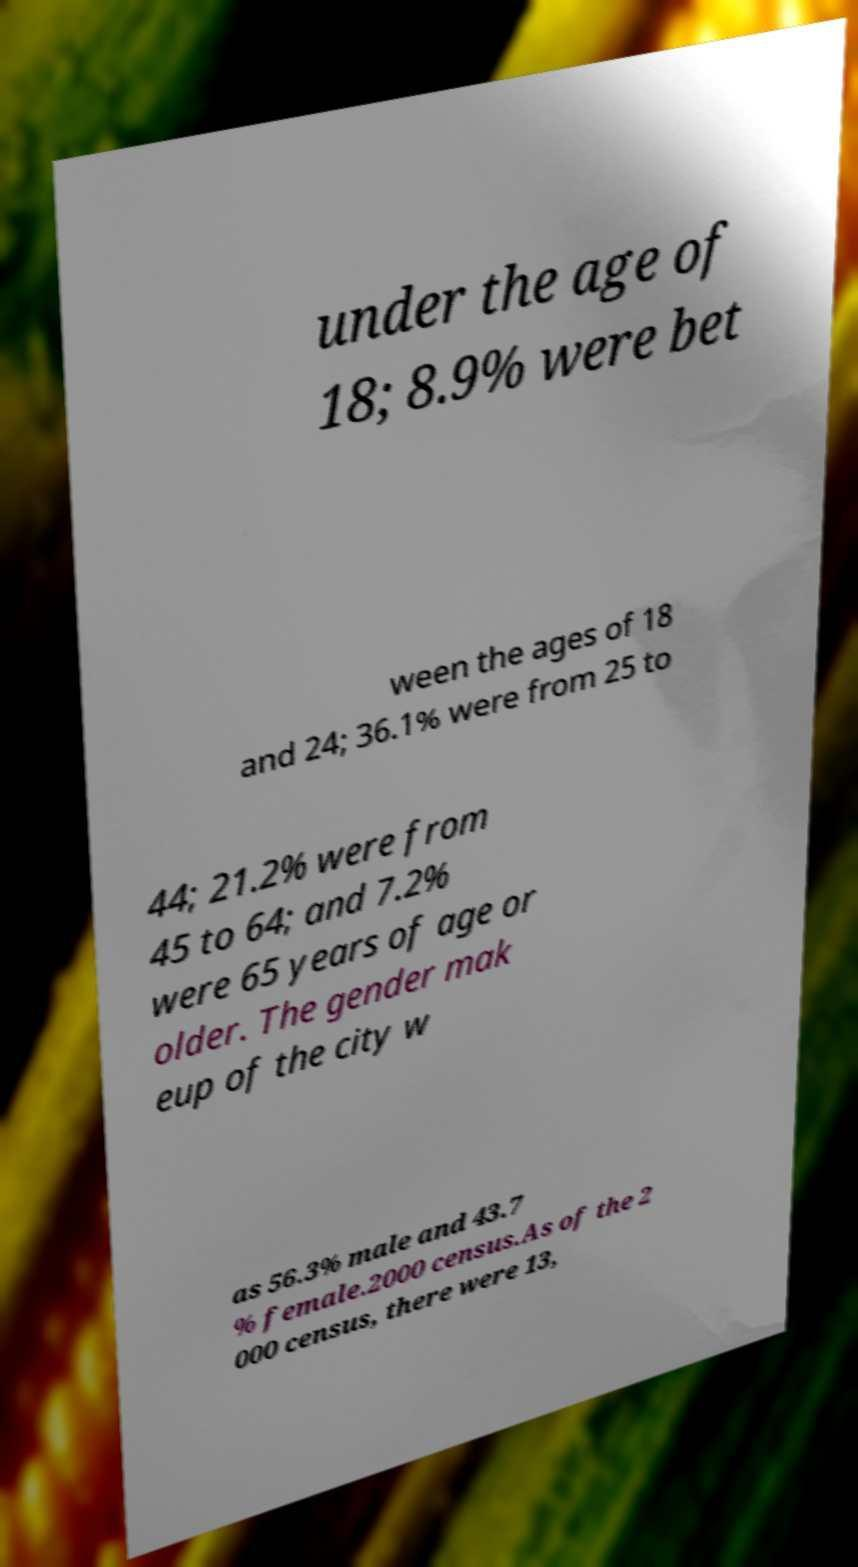I need the written content from this picture converted into text. Can you do that? under the age of 18; 8.9% were bet ween the ages of 18 and 24; 36.1% were from 25 to 44; 21.2% were from 45 to 64; and 7.2% were 65 years of age or older. The gender mak eup of the city w as 56.3% male and 43.7 % female.2000 census.As of the 2 000 census, there were 13, 